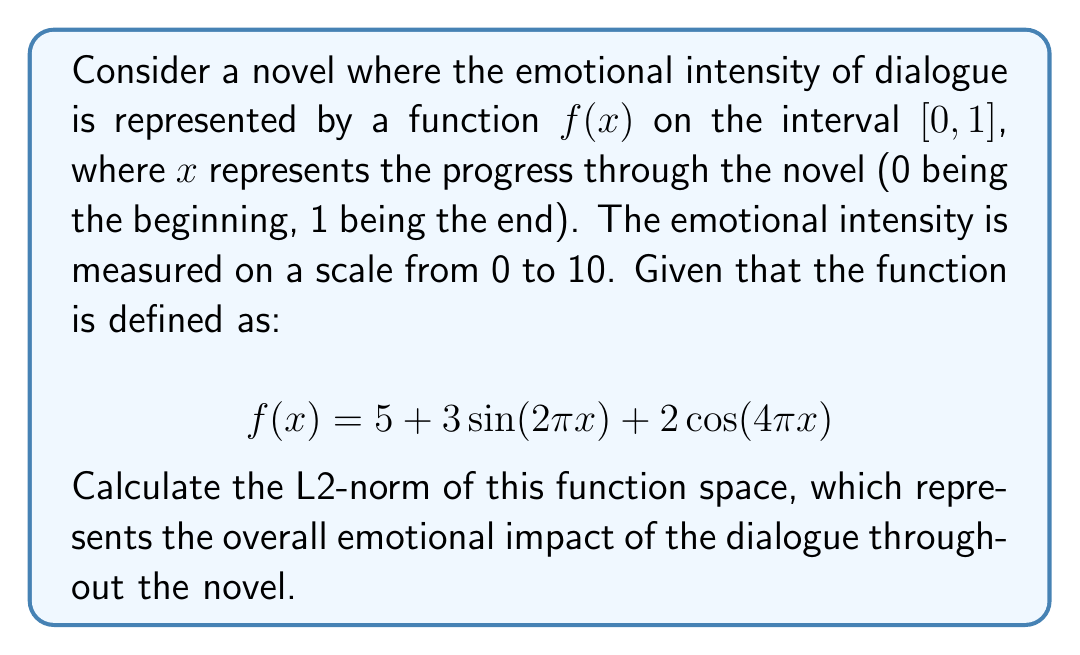Can you solve this math problem? To solve this problem, we'll follow these steps:

1) The L2-norm of a function $f(x)$ on an interval $[a, b]$ is defined as:

   $$\|f\|_2 = \sqrt{\int_a^b |f(x)|^2 dx}$$

2) In our case, $a = 0$, $b = 1$, and $f(x) = 5 + 3\sin(2\pi x) + 2\cos(4\pi x)$

3) We need to calculate $\int_0^1 |f(x)|^2 dx$. Let's expand this:

   $$\int_0^1 (5 + 3\sin(2\pi x) + 2\cos(4\pi x))^2 dx$$

4) Expanding the square:

   $$\int_0^1 (25 + 30\sin(2\pi x) + 20\cos(4\pi x) + 9\sin^2(2\pi x) + 12\sin(2\pi x)\cos(4\pi x) + 4\cos^2(4\pi x)) dx$$

5) Now, let's integrate each term:

   - $\int_0^1 25 dx = 25$
   - $\int_0^1 30\sin(2\pi x) dx = 0$ (sine integrates to 0 over a full period)
   - $\int_0^1 20\cos(4\pi x) dx = 0$ (cosine integrates to 0 over a full period)
   - $\int_0^1 9\sin^2(2\pi x) dx = \frac{9}{2}$ (average value of $\sin^2$ is 1/2)
   - $\int_0^1 12\sin(2\pi x)\cos(4\pi x) dx = 0$ (product of different frequency sine and cosine integrates to 0)
   - $\int_0^1 4\cos^2(4\pi x) dx = 2$ (average value of $\cos^2$ is 1/2)

6) Adding these up:

   $$25 + 0 + 0 + \frac{9}{2} + 0 + 2 = \frac{61}{2}$$

7) Finally, we take the square root:

   $$\|f\|_2 = \sqrt{\frac{61}{2}}$$
Answer: $$\|f\|_2 = \sqrt{\frac{61}{2}} \approx 5.5227$$ 